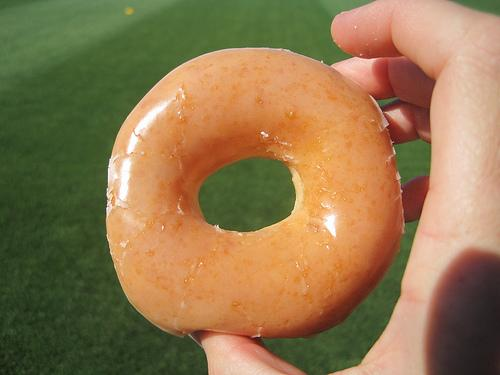Can you identify the main object in the image and describe its shape and color with a short phrase? A round, brown doughnut with a hole in the middle. Mention any three distinguishing features of the doughnut in the image. The doughnut is round, brown, and has a hole in the middle. Enumerate and describe the type of vegetation you find in the image. There is green vegetation in various patches, including grass, which seems to be fresh. How many fingers are visible in the image, and what are their positions? There are four fingers visible at the top of the image, and one at the bottom right corner. What is the emotional context or sentiment of the image? The image conveys a playful, positive sentiment with the doughnut being held up. Where is the grass located in the image, and what can be said about its freshness? The grass is located in patches around the image, and it appears to be fresh. How many instances of the same object are mentioned in the captions? Four instances of fingers and twenty instances of a doughnut. Infer the possible interaction between the doughnut and the fingers in the image. The fingers could be holding up or touching the doughnut, likely presenting it to be admired or eaten. 